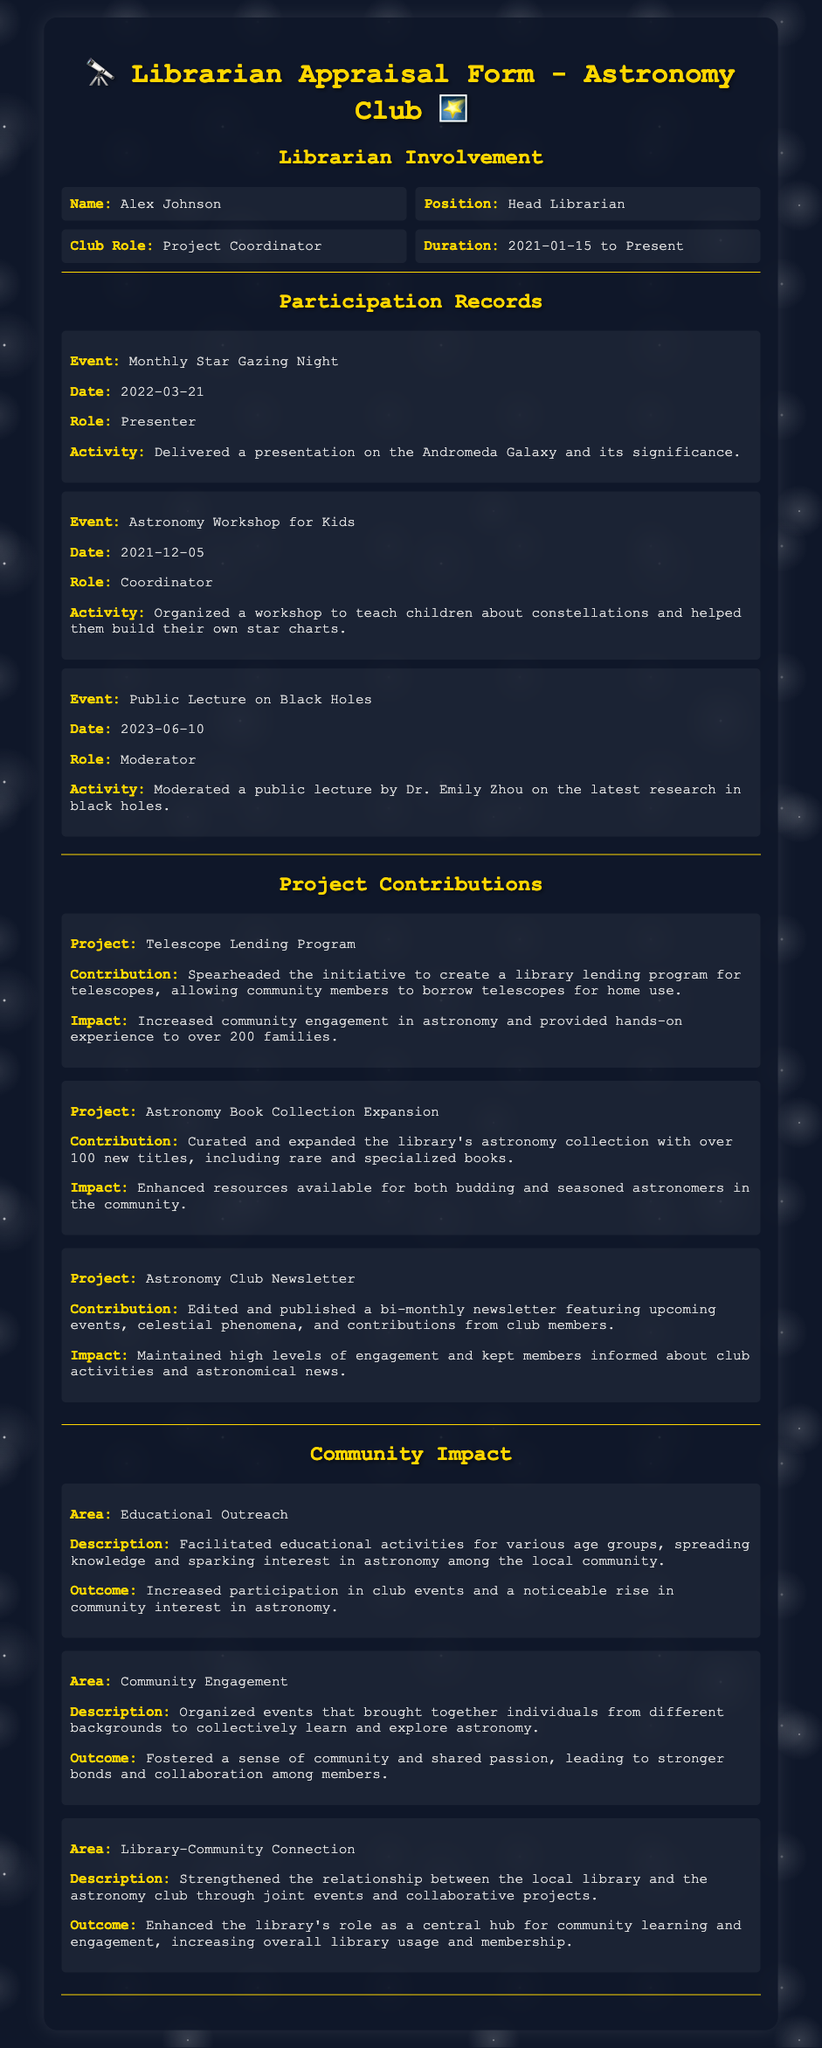What is the name of the librarian? The librarian's name is provided in the document under the "Librarian Involvement" section.
Answer: Alex Johnson What is the librarian's role in the club? The role of the librarian in the club is specified in the same section, detailing their position.
Answer: Project Coordinator When did the Astronomy Workshop for Kids take place? The date of the event is found in the "Participation Records" section.
Answer: 2021-12-05 How many new titles were added to the astronomy collection? The specific contribution about the number of new titles is mentioned in the "Project Contributions" section.
Answer: Over 100 What was the outcome of the educational outreach activities? The outcomes for different areas in the "Community Impact" section provide insights into the results of the librarian's efforts.
Answer: Increased participation in club events What role did Alex Johnson play in the Public Lecture on Black Holes? This information can be located in the details about their participation in the event.
Answer: Moderator What project aimed to facilitate telescope lending? The project title is mentioned in the "Project Contributions" section along with its contribution.
Answer: Telescope Lending Program How has the library's role changed due to community engagement efforts? Insights about the changes in the library's role are provided under community impact descriptions.
Answer: Enhanced the library's role as a central hub What type of educational activities did the librarian facilitate? The description in the "Community Impact" section outlines the activities provided.
Answer: Educational activities Which project involved publishing a newsletter? The project name associated with publishing the newsletter is found in the "Project Contributions" section.
Answer: Astronomy Club Newsletter 